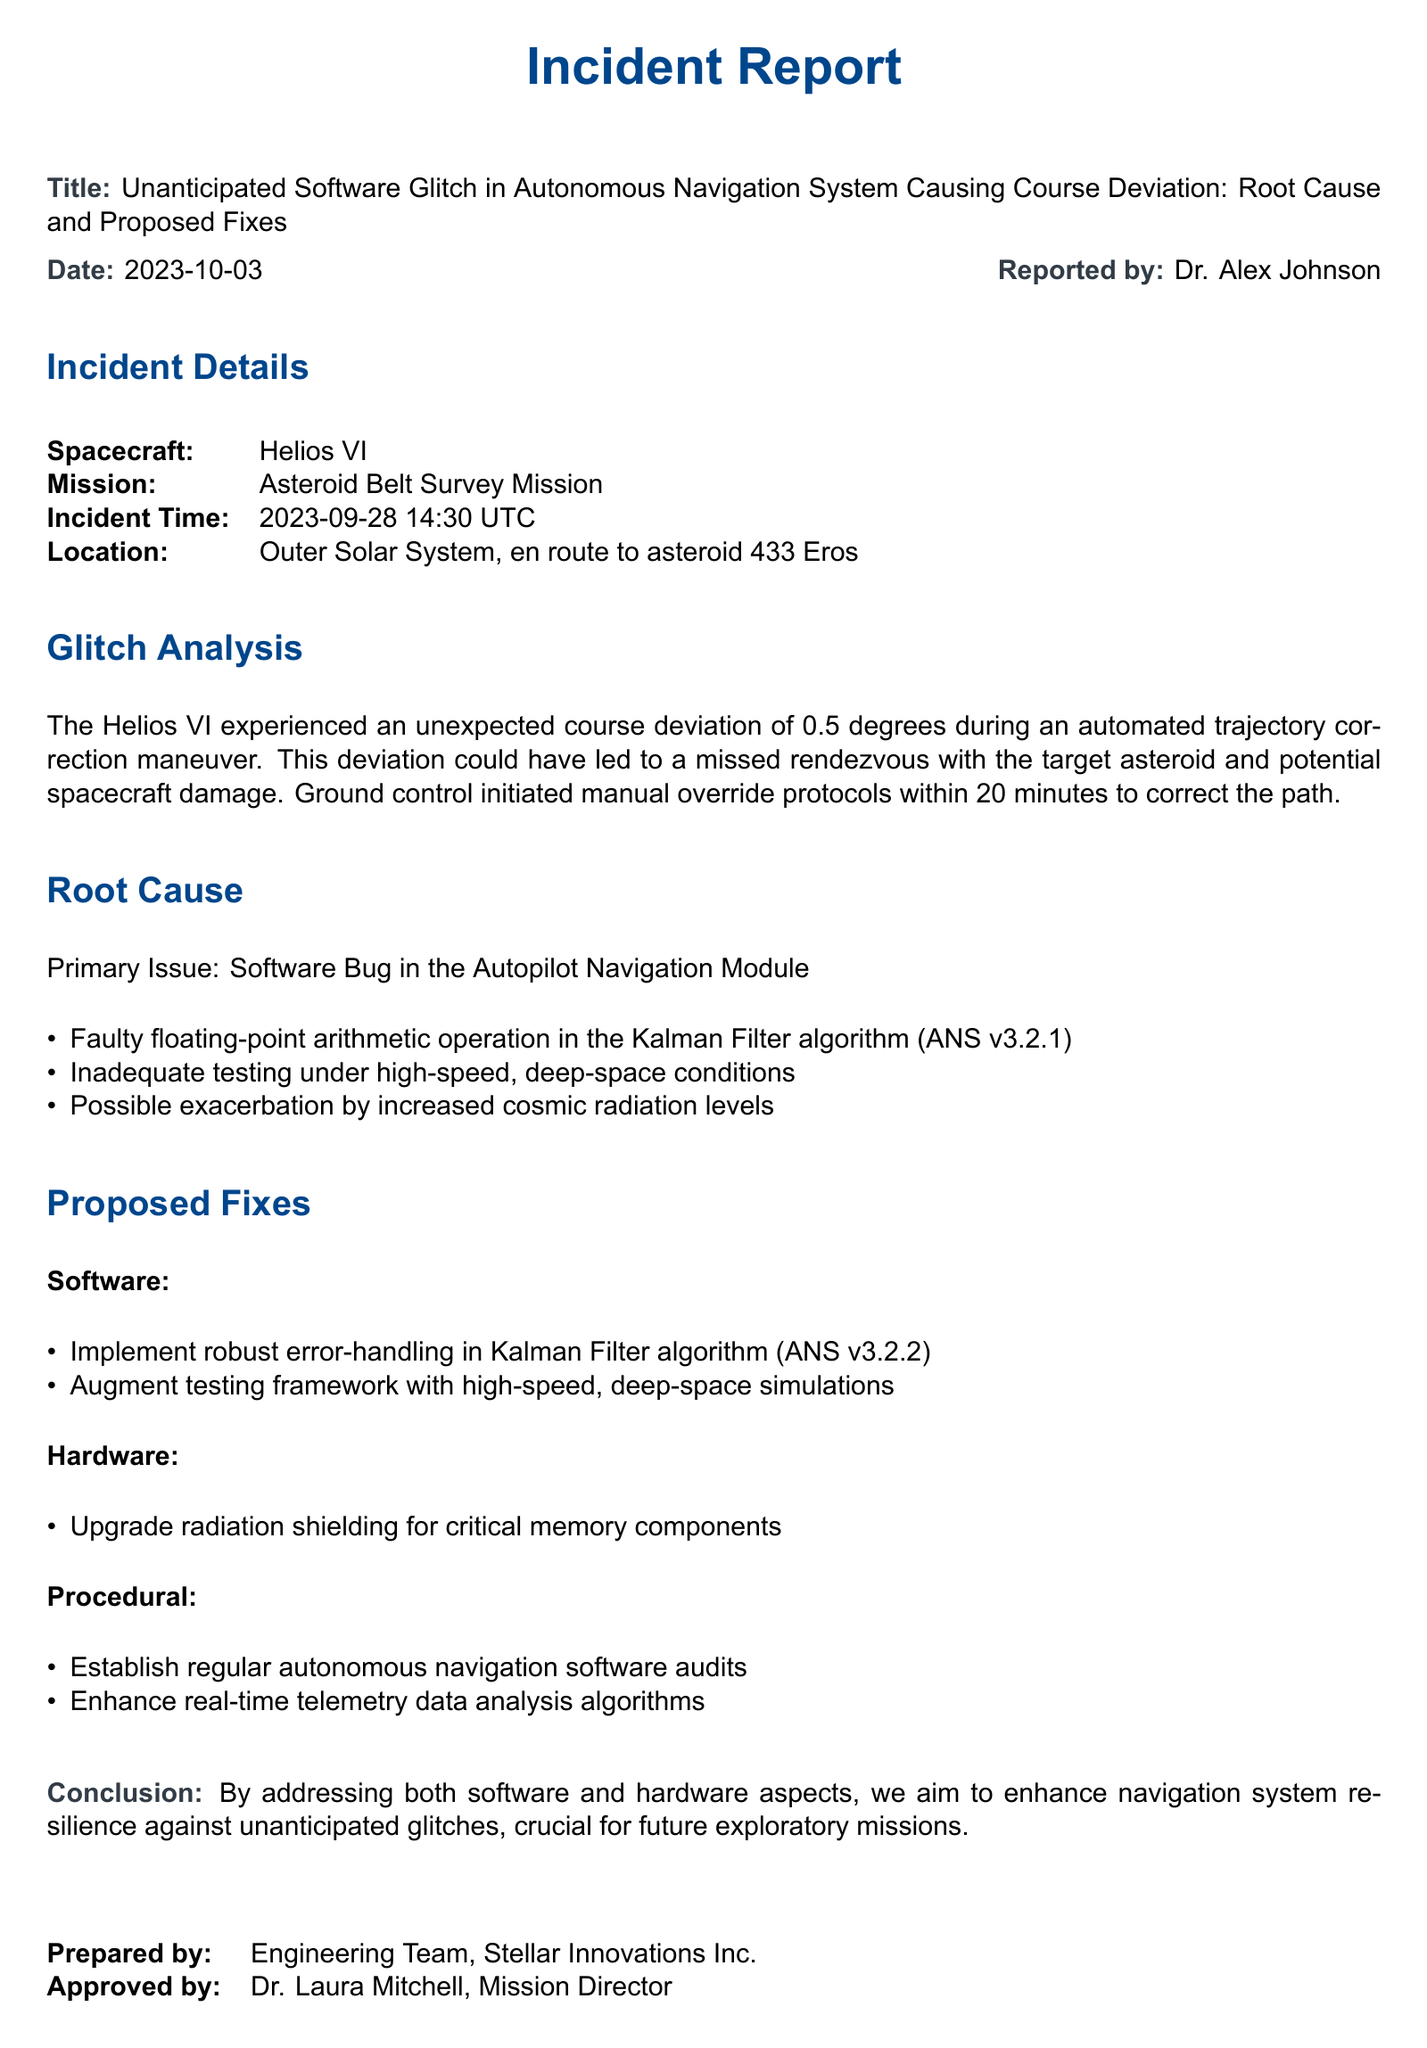what is the title of the incident report? The title is explicitly stated at the beginning of the document under the header text.
Answer: Unanticipated Software Glitch in Autonomous Navigation System Causing Course Deviation: Root Cause and Proposed Fixes who reported the incident? The report includes the name of the person who prepared it.
Answer: Dr. Alex Johnson what was the incident time? The timing details of the incident are specified in the incident details section.
Answer: 2023-09-28 14:30 UTC what primary issue caused the glitch? The root cause section outlines the main issue leading to the unanticipated course deviation.
Answer: Software Bug in the Autopilot Navigation Module how much was the course deviation? The glitch analysis section provides a numerical value for the deviation experienced by the spacecraft.
Answer: 0.5 degrees what software version contains the Kalman Filter algorithm that had the bug? The document specifies the version of the Autopilot Navigation System that contains the faulty algorithm.
Answer: ANS v3.2.1 what is one of the proposed software fixes? The proposed fixes section lists actions to address the identified issue, highlighting specific recommendations.
Answer: Implement robust error-handling in Kalman Filter algorithm (ANS v3.2.2) who approved the incident report? The document includes the name of the person who approved the report at the end.
Answer: Dr. Laura Mitchell, Mission Director 